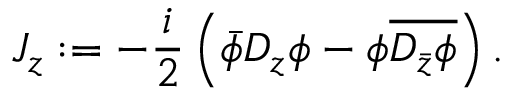Convert formula to latex. <formula><loc_0><loc_0><loc_500><loc_500>J _ { z } \colon = - \frac { i } { 2 } \left ( \bar { \phi } D _ { z } \phi - \phi \overline { { { D _ { \bar { z } } \phi } } } \right ) .</formula> 